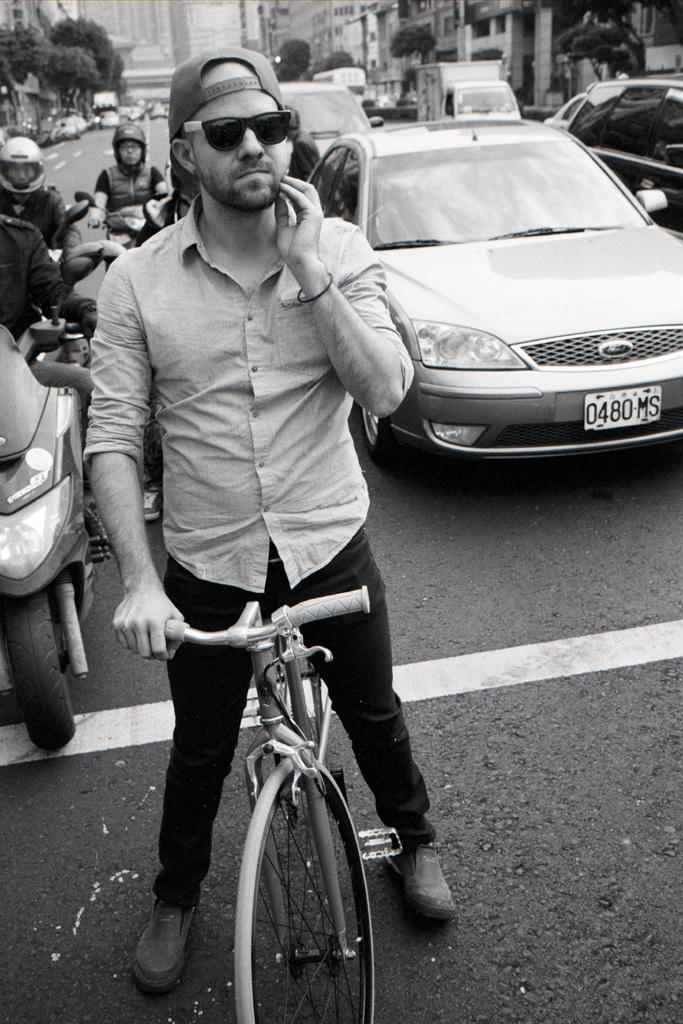What can be seen in the image related to transportation? There are vehicles in the image. Where are the vehicles located? The vehicles are standing on the road. Are there any people present in the image? Yes, there are people in the image. What type of curtain can be seen hanging in the image? There is no curtain present in the image. What kind of loaf is being prepared by the people in the image? There is no loaf or baking activity depicted in the image. 